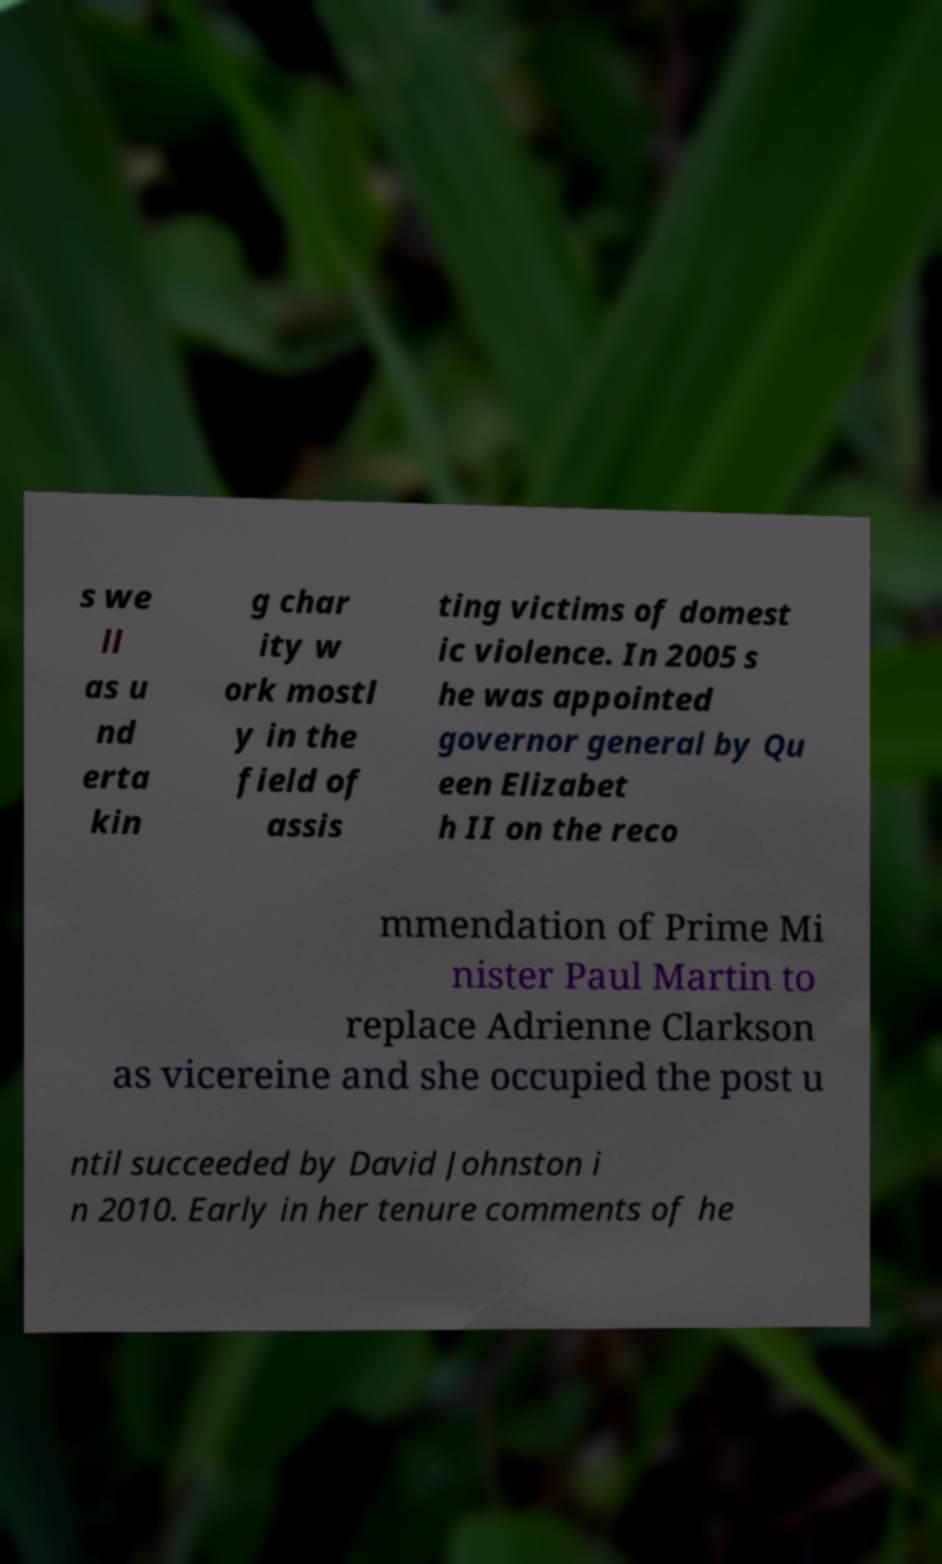Can you accurately transcribe the text from the provided image for me? s we ll as u nd erta kin g char ity w ork mostl y in the field of assis ting victims of domest ic violence. In 2005 s he was appointed governor general by Qu een Elizabet h II on the reco mmendation of Prime Mi nister Paul Martin to replace Adrienne Clarkson as vicereine and she occupied the post u ntil succeeded by David Johnston i n 2010. Early in her tenure comments of he 